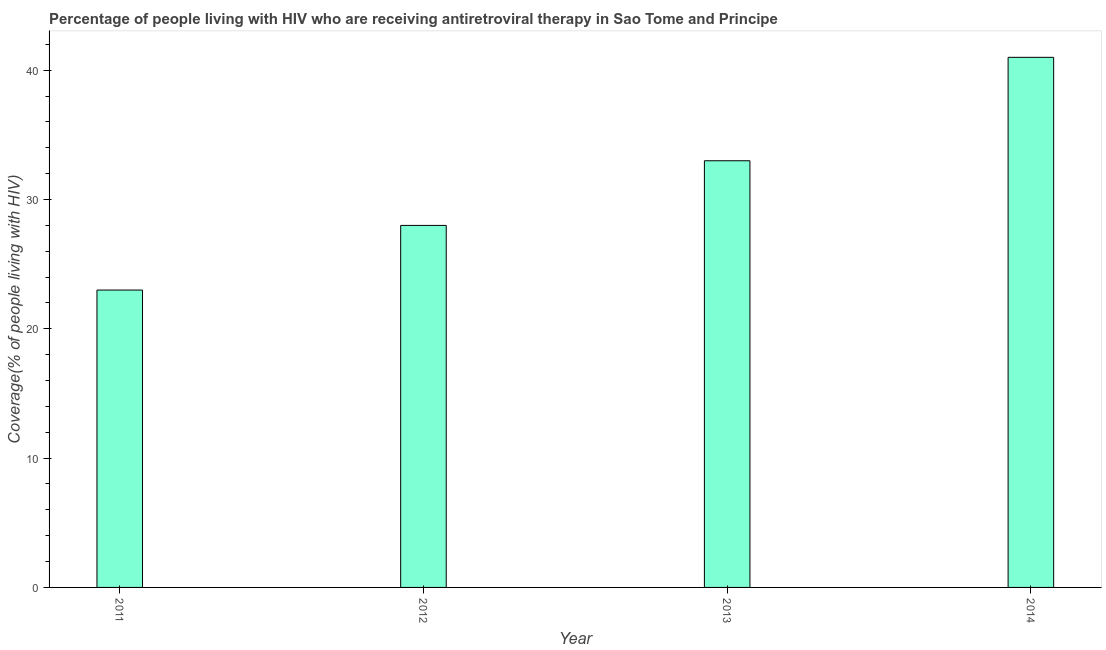Does the graph contain any zero values?
Give a very brief answer. No. What is the title of the graph?
Provide a short and direct response. Percentage of people living with HIV who are receiving antiretroviral therapy in Sao Tome and Principe. What is the label or title of the Y-axis?
Give a very brief answer. Coverage(% of people living with HIV). What is the antiretroviral therapy coverage in 2013?
Keep it short and to the point. 33. Across all years, what is the maximum antiretroviral therapy coverage?
Your answer should be very brief. 41. What is the sum of the antiretroviral therapy coverage?
Provide a short and direct response. 125. What is the median antiretroviral therapy coverage?
Offer a terse response. 30.5. Do a majority of the years between 2011 and 2013 (inclusive) have antiretroviral therapy coverage greater than 32 %?
Keep it short and to the point. No. What is the ratio of the antiretroviral therapy coverage in 2011 to that in 2014?
Your response must be concise. 0.56. What is the difference between the highest and the second highest antiretroviral therapy coverage?
Provide a short and direct response. 8. Is the sum of the antiretroviral therapy coverage in 2011 and 2014 greater than the maximum antiretroviral therapy coverage across all years?
Offer a very short reply. Yes. In how many years, is the antiretroviral therapy coverage greater than the average antiretroviral therapy coverage taken over all years?
Your answer should be very brief. 2. Are all the bars in the graph horizontal?
Keep it short and to the point. No. What is the difference between two consecutive major ticks on the Y-axis?
Give a very brief answer. 10. What is the Coverage(% of people living with HIV) in 2012?
Offer a terse response. 28. What is the Coverage(% of people living with HIV) of 2014?
Your response must be concise. 41. What is the difference between the Coverage(% of people living with HIV) in 2011 and 2013?
Your answer should be very brief. -10. What is the difference between the Coverage(% of people living with HIV) in 2012 and 2013?
Offer a very short reply. -5. What is the difference between the Coverage(% of people living with HIV) in 2012 and 2014?
Your response must be concise. -13. What is the ratio of the Coverage(% of people living with HIV) in 2011 to that in 2012?
Keep it short and to the point. 0.82. What is the ratio of the Coverage(% of people living with HIV) in 2011 to that in 2013?
Offer a terse response. 0.7. What is the ratio of the Coverage(% of people living with HIV) in 2011 to that in 2014?
Your answer should be compact. 0.56. What is the ratio of the Coverage(% of people living with HIV) in 2012 to that in 2013?
Give a very brief answer. 0.85. What is the ratio of the Coverage(% of people living with HIV) in 2012 to that in 2014?
Make the answer very short. 0.68. What is the ratio of the Coverage(% of people living with HIV) in 2013 to that in 2014?
Your answer should be compact. 0.81. 